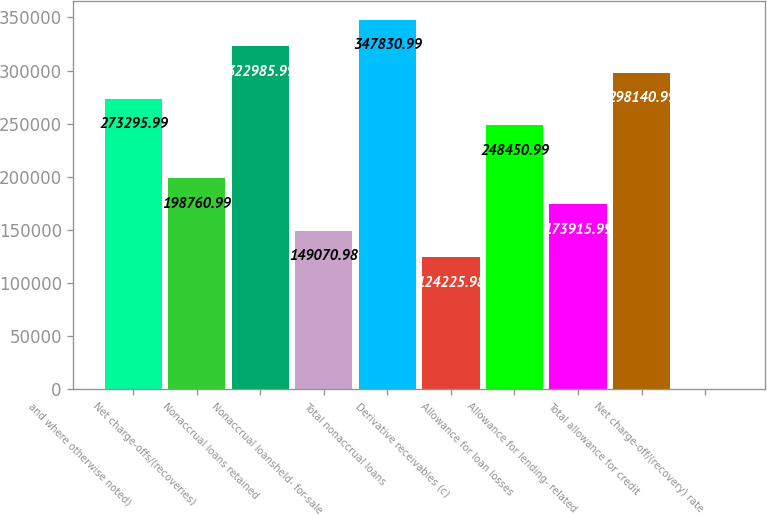<chart> <loc_0><loc_0><loc_500><loc_500><bar_chart><fcel>and where otherwise noted)<fcel>Net charge-offs/(recoveries)<fcel>Nonaccrual loans retained<fcel>Nonaccrual loansheld- for-sale<fcel>Total nonaccrual loans<fcel>Derivative receivables (c)<fcel>Allowance for loan losses<fcel>Allowance for lending- related<fcel>Total allowance for credit<fcel>Net charge-off/(recovery) rate<nl><fcel>273296<fcel>198761<fcel>322986<fcel>149071<fcel>347831<fcel>124226<fcel>248451<fcel>173916<fcel>298141<fcel>0.95<nl></chart> 